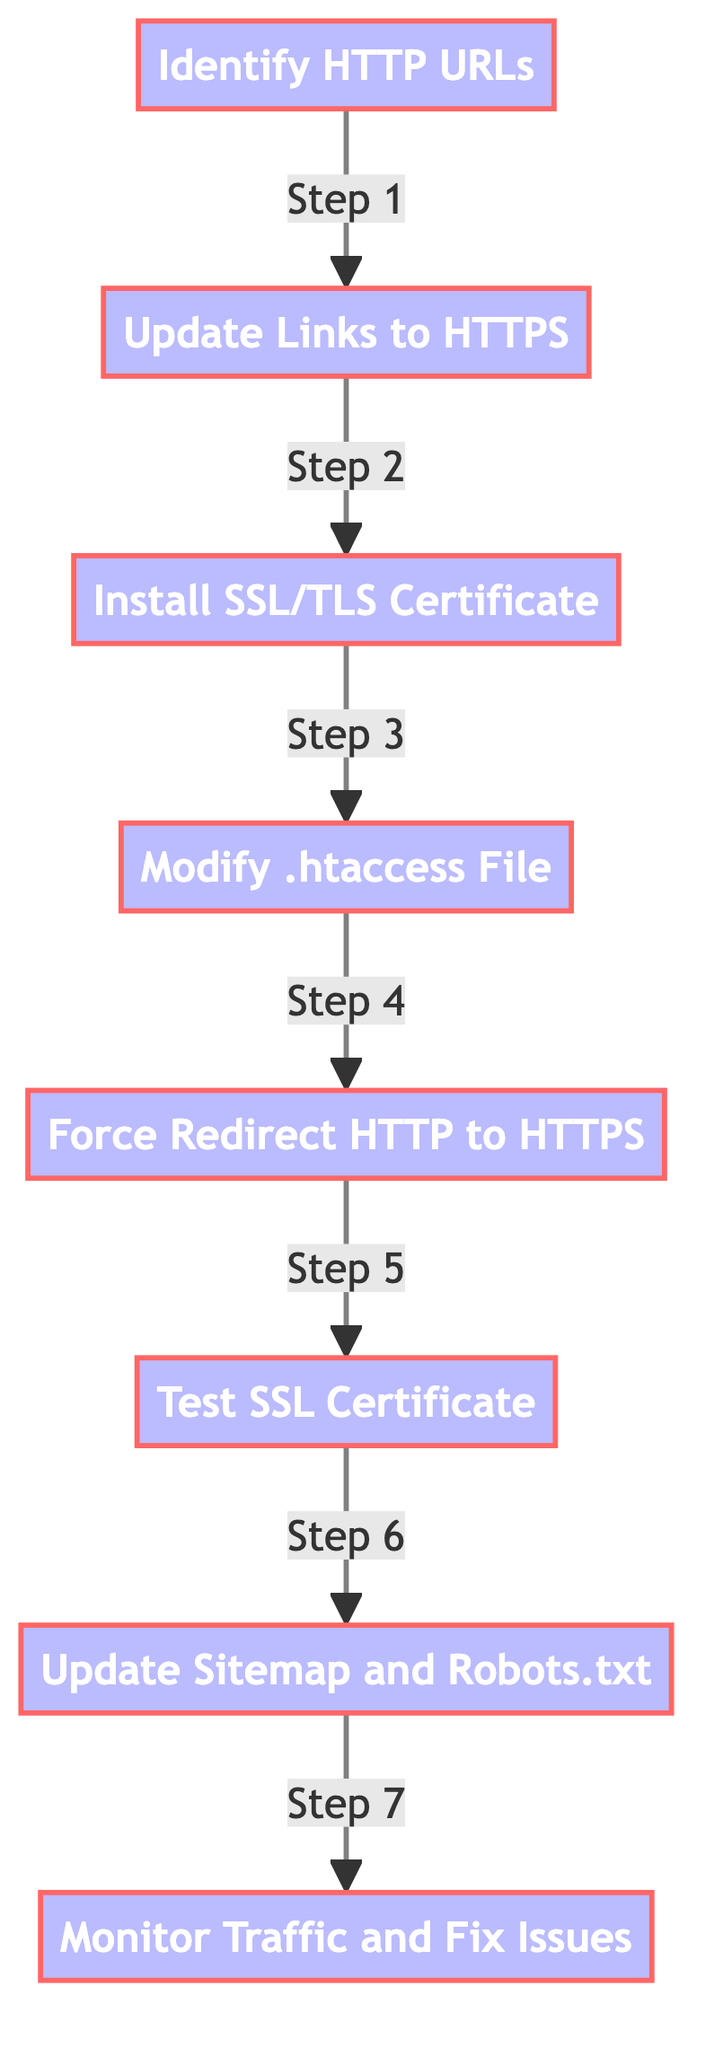What is the first step in migrating to HTTPS? The diagram starts with the node labeled "Identify HTTP URLs," indicating that this is the first step in the migration process.
Answer: Identify HTTP URLs How many nodes are there in the migration process? Counting the nodes listed in the diagram, there are eight distinct nodes that represent different steps in the migration process.
Answer: 8 What step follows "Install SSL/TLS Certificate"? The diagram shows that the step labeled "Modify .htaccess File" follows directly after "Install SSL/TLS Certificate," indicating the sequence of the process.
Answer: Modify .htaccess File Which step is labeled as Step 5? The edge labeled "Step 5" connects the node "Force Redirect HTTP to HTTPS," which corresponds to the action taken during this specific part of the process.
Answer: Force Redirect HTTP to HTTPS What is the final step in the migration process? The last node in the diagram is "Monitor Traffic and Fix Issues," indicating that this is the final step to ensure proper migration to HTTPS.
Answer: Monitor Traffic and Fix Issues Which two steps are directly connected before the "Test SSL Certificate"? The edge connecting "Force Redirect HTTP to HTTPS" and "Test SSL Certificate" indicates these two steps are directly sequential in the process.
Answer: Force Redirect HTTP to HTTPS and Test SSL Certificate What is the relationship between "Update Links to HTTPS" and "Install SSL/TLS Certificate"? The diagram indicates a direct edge from "Update Links to HTTPS" to "Install SSL/TLS Certificate," meaning the latter follows the completion of the former.
Answer: Step 2 What action occurs after modifying the .htaccess file? According to the flow of the diagram, the action that occurs after modifying the .htaccess file is to "Force Redirect HTTP to HTTPS."
Answer: Force Redirect HTTP to HTTPS 